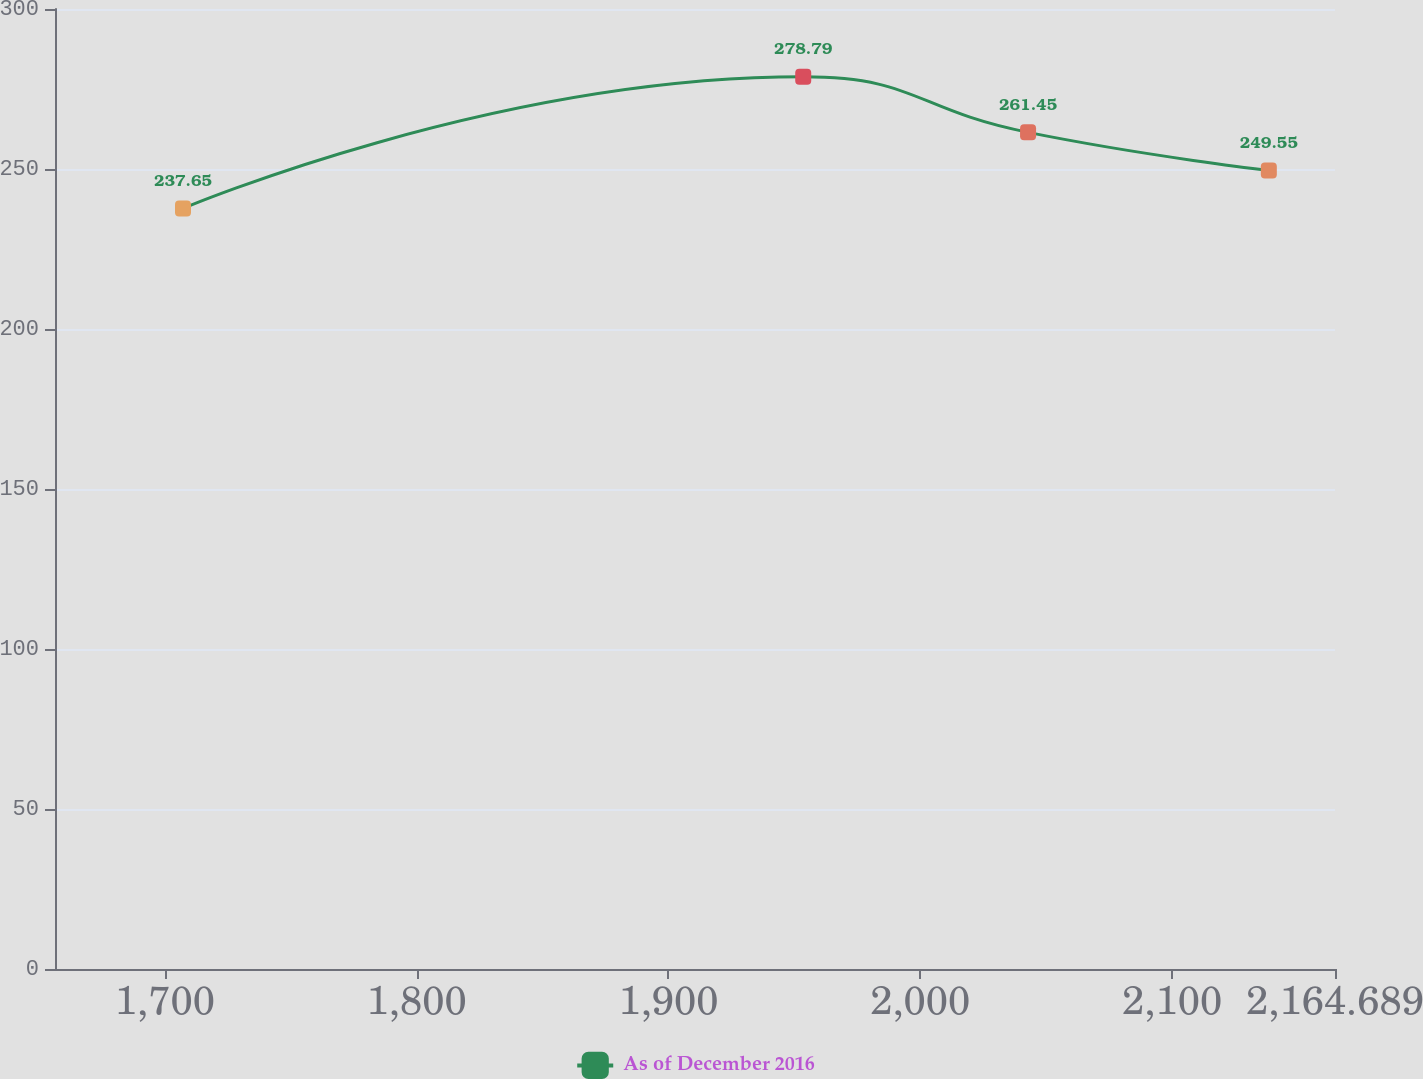<chart> <loc_0><loc_0><loc_500><loc_500><line_chart><ecel><fcel>As of December 2016<nl><fcel>1707.21<fcel>237.65<nl><fcel>1953.51<fcel>278.79<nl><fcel>2042.8<fcel>261.45<nl><fcel>2138.41<fcel>249.55<nl><fcel>2215.52<fcel>159.79<nl></chart> 